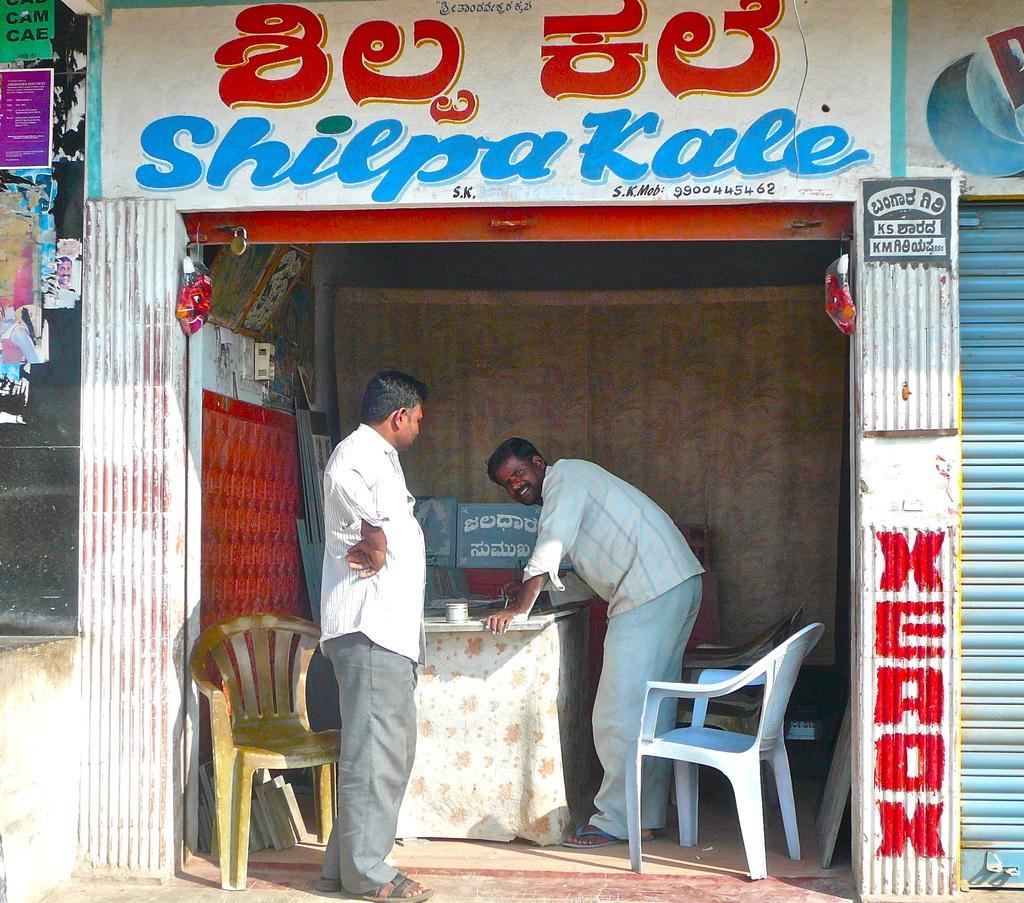Could you give a brief overview of what you see in this image? This image consists of a store where Shilpakale is written on it. There are two persons in this shop. There is a table and three chairs. There is a curtain behind one man. There is another shop beside that shop in the right side. There is xerox written near the shop. 